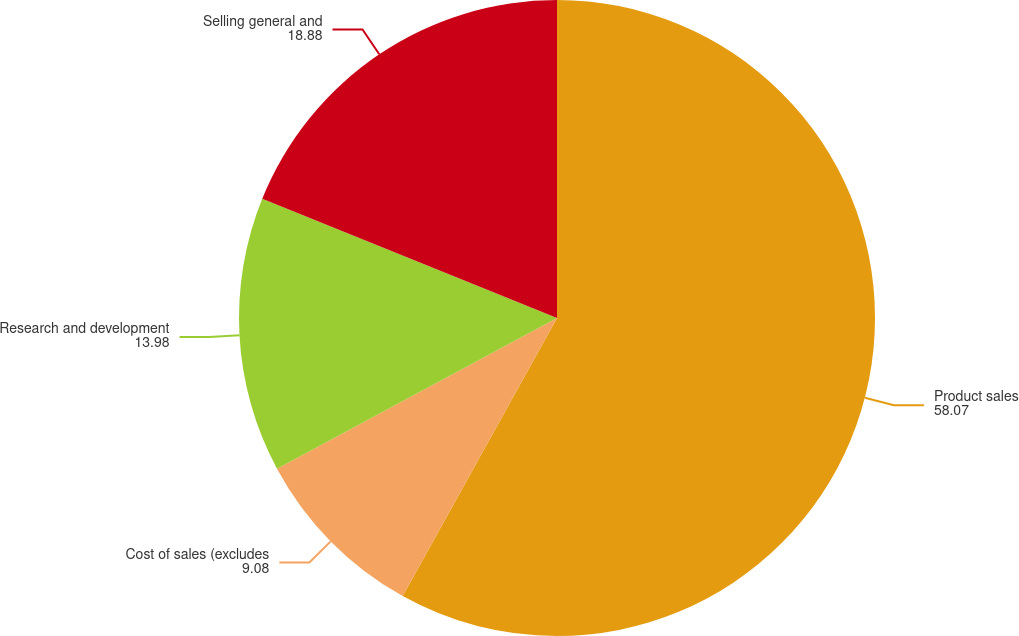Convert chart. <chart><loc_0><loc_0><loc_500><loc_500><pie_chart><fcel>Product sales<fcel>Cost of sales (excludes<fcel>Research and development<fcel>Selling general and<nl><fcel>58.07%<fcel>9.08%<fcel>13.98%<fcel>18.88%<nl></chart> 